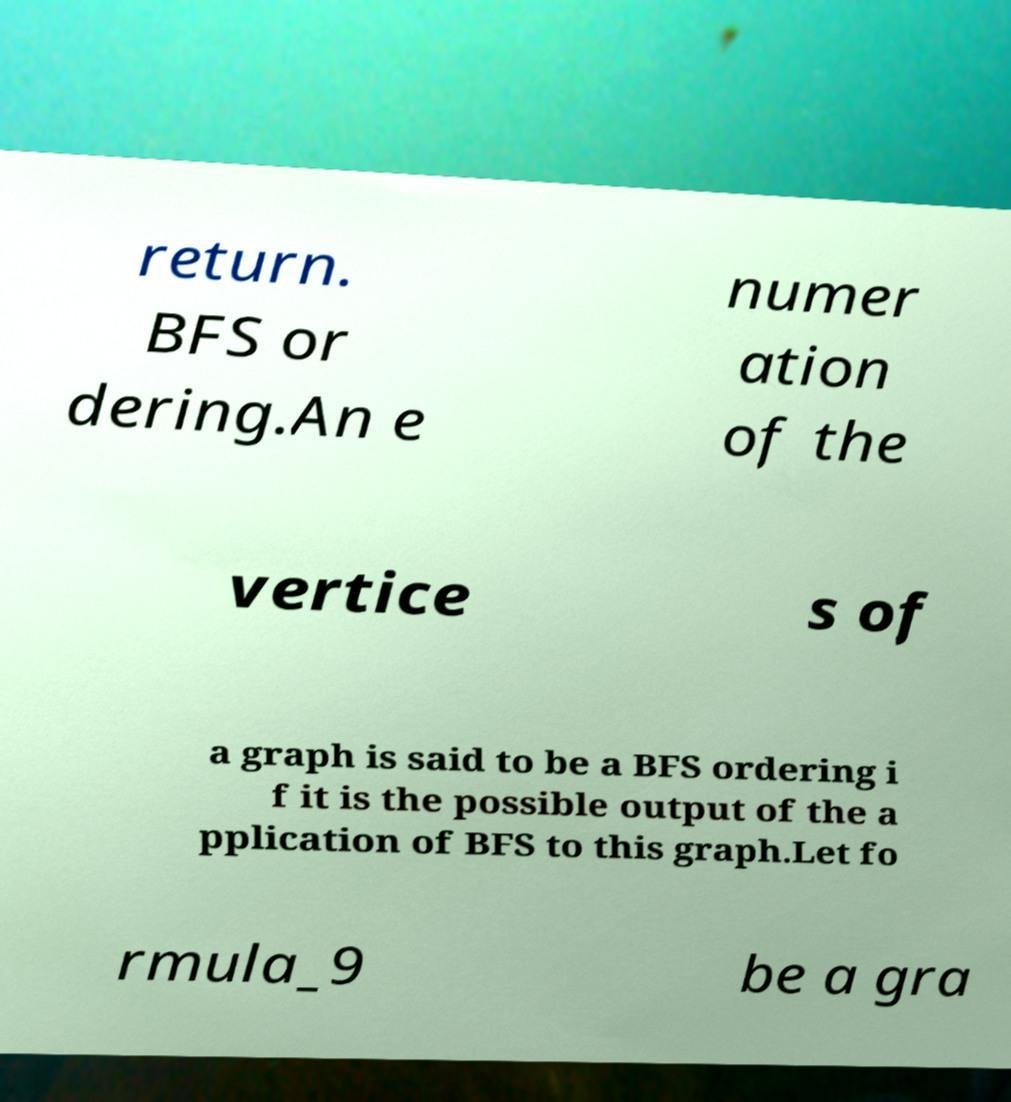Can you accurately transcribe the text from the provided image for me? return. BFS or dering.An e numer ation of the vertice s of a graph is said to be a BFS ordering i f it is the possible output of the a pplication of BFS to this graph.Let fo rmula_9 be a gra 